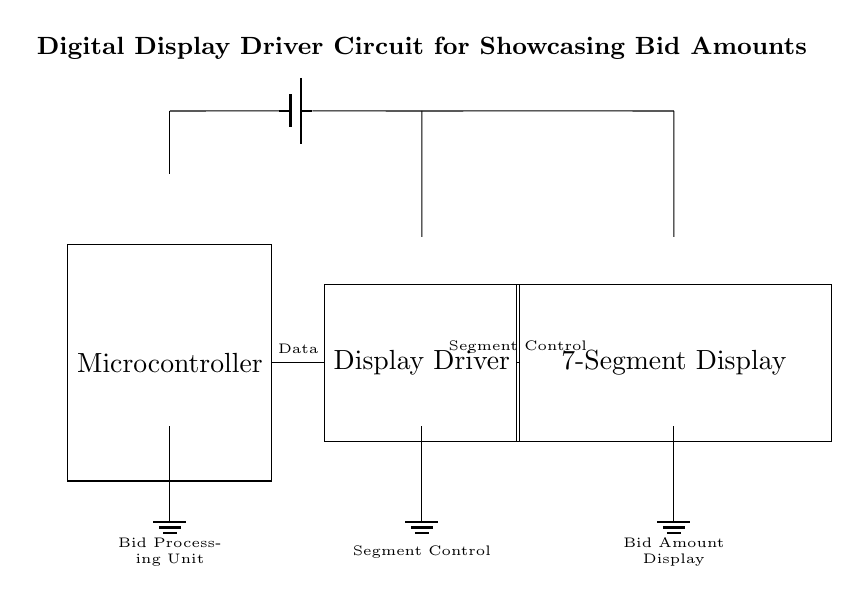What components are present in the circuit? The circuit includes a microcontroller, a display driver, and a 7-segment display, which are clearly labeled in the diagram.
Answer: Microcontroller, display driver, 7-segment display What type of display is used to show the bid amount? The diagram specifies that the display component is a 7-segment display, which is commonly used for visual output in electronic circuits.
Answer: 7-segment display How does the microcontroller communicate with the display driver? The diagram shows a connection labeled as "Data" from the microcontroller to the display driver, indicating that the microcontroller sends digital information to control the display.
Answer: Data What is the primary purpose of the display driver in this circuit? The display driver serves to control the segments of the 7-segment display according to the data received from the microcontroller, translating the input into a visible output.
Answer: Control display segments How is power supplied to the circuit? The circuit includes a battery symbol connected at the top, indicating that the power supply comes from a battery, which feeds the voltage to the components.
Answer: Battery What does the label “Bid Processing Unit” refer to? The “Bid Processing Unit” label indicates that it is responsible for managing the bid amounts and processing data before sending it to the display driver.
Answer: Bid Processing Unit Why is grounding important in this circuit? Grounding provides a common reference point for the voltage levels in the circuit, helps to stabilize the circuit, and ensures safe operation by preventing electrical shock or damage.
Answer: Stabilization and safety 